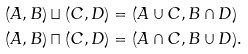<formula> <loc_0><loc_0><loc_500><loc_500>( A , B ) \sqcup ( C , D ) & = ( A \cup C , B \cap D ) \\ ( A , B ) \sqcap ( C , D ) & = ( A \cap C , B \cup D ) .</formula> 